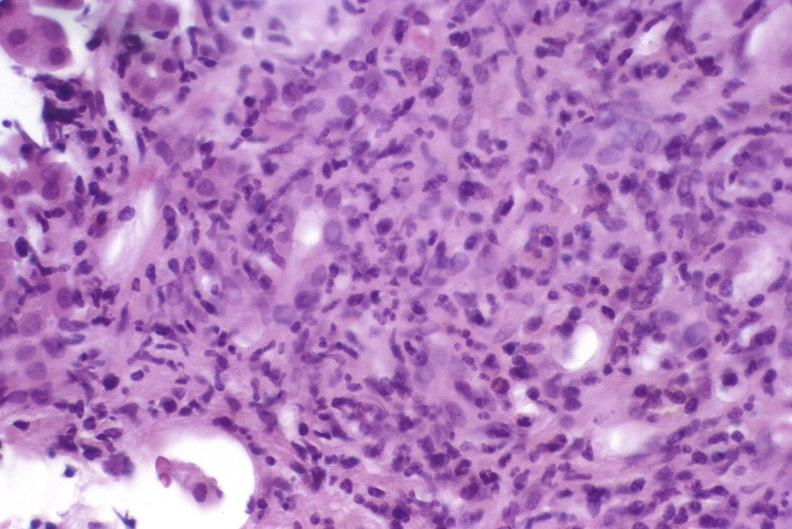s liver present?
Answer the question using a single word or phrase. Yes 